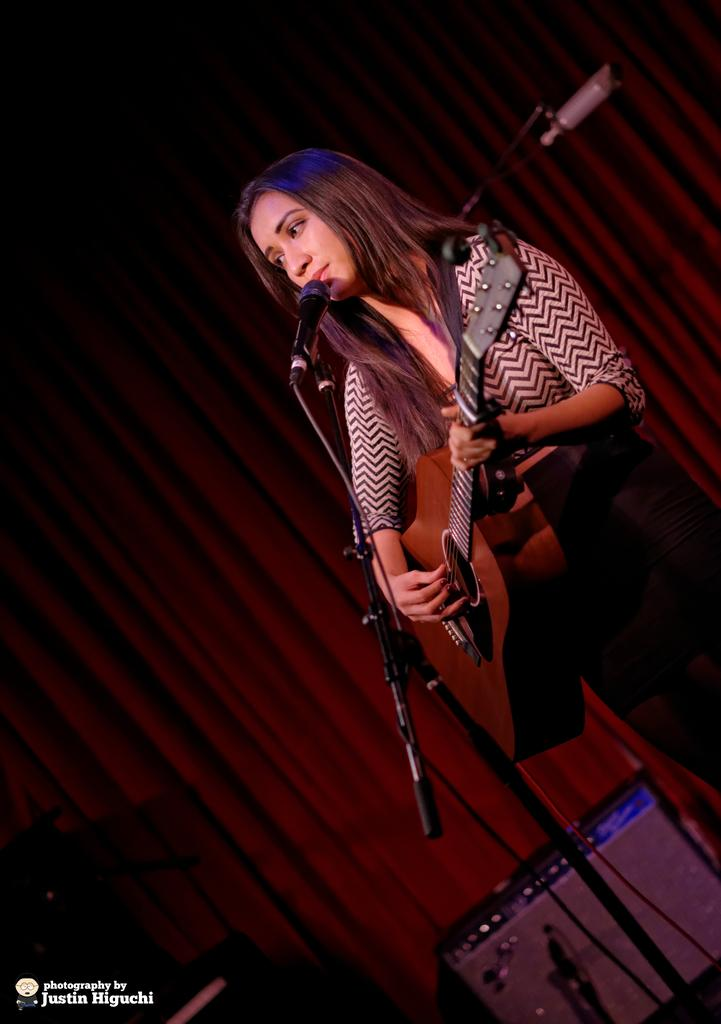Who is the main subject in the image? There is a woman in the image. What is the woman doing in the image? The woman is standing, playing a guitar, and singing. What is the woman standing in front of? The woman is in front of a microphone. What can be seen in the background of the image? There is a curtain in the background of the image. What brand of toothpaste is the woman using in the image? There is no toothpaste present in the image. How many trains can be seen in the background of the image? There are no trains visible in the image; only a curtain is present in the background. 